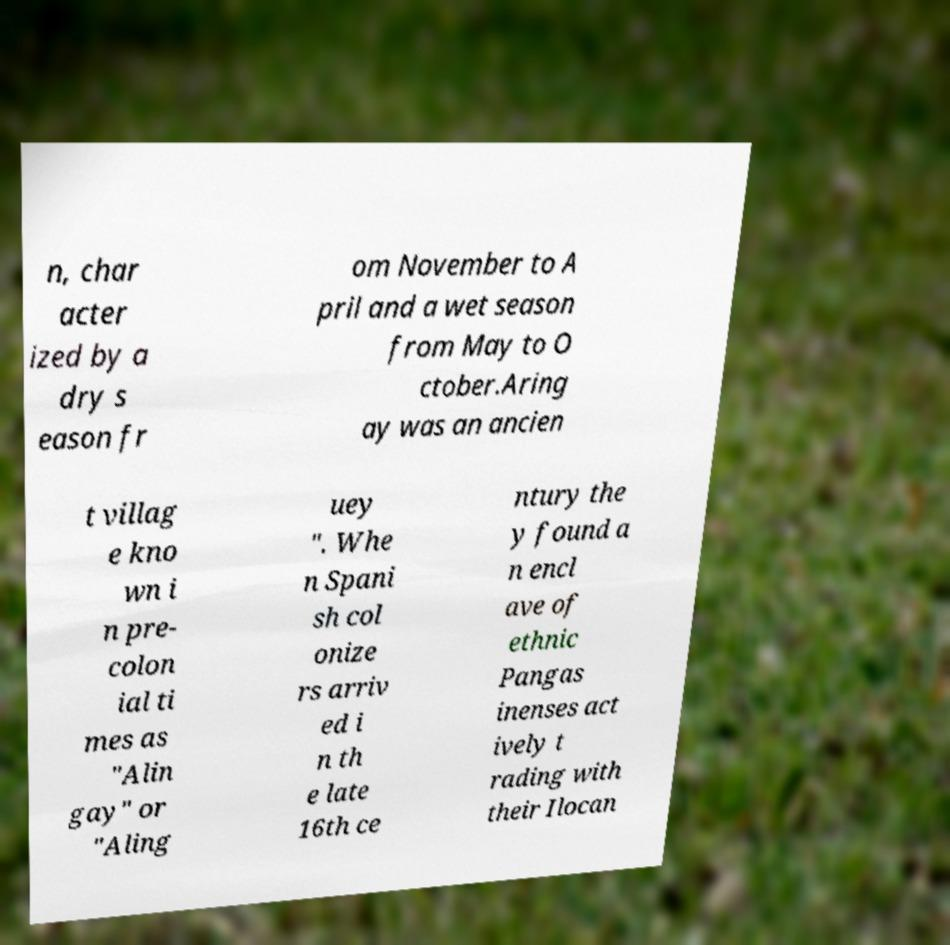Can you read and provide the text displayed in the image?This photo seems to have some interesting text. Can you extract and type it out for me? n, char acter ized by a dry s eason fr om November to A pril and a wet season from May to O ctober.Aring ay was an ancien t villag e kno wn i n pre- colon ial ti mes as "Alin gay" or "Aling uey ". Whe n Spani sh col onize rs arriv ed i n th e late 16th ce ntury the y found a n encl ave of ethnic Pangas inenses act ively t rading with their Ilocan 